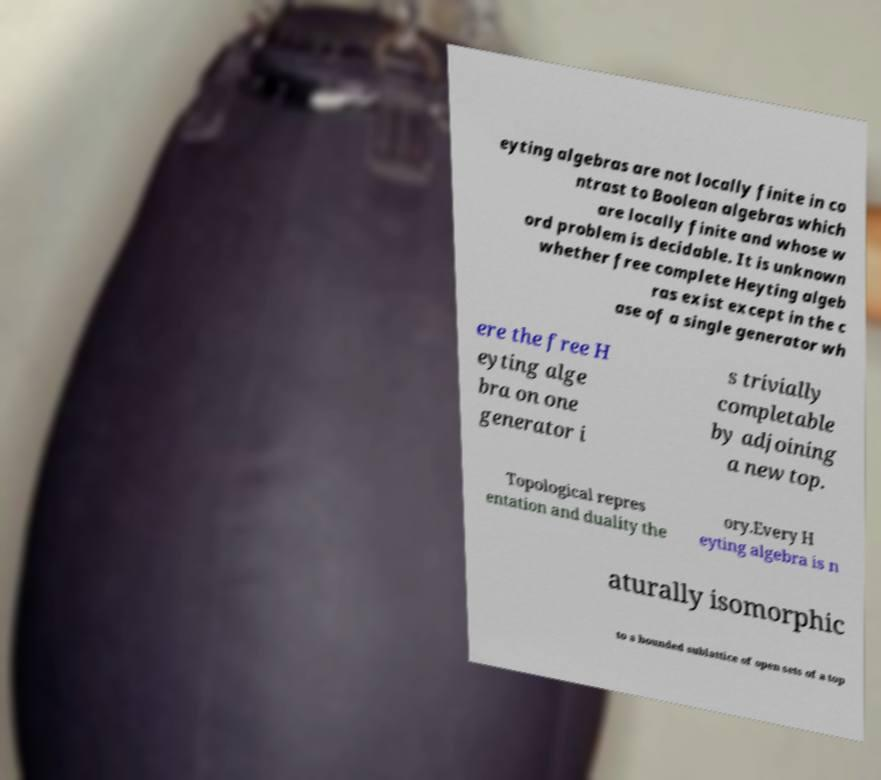Can you accurately transcribe the text from the provided image for me? eyting algebras are not locally finite in co ntrast to Boolean algebras which are locally finite and whose w ord problem is decidable. It is unknown whether free complete Heyting algeb ras exist except in the c ase of a single generator wh ere the free H eyting alge bra on one generator i s trivially completable by adjoining a new top. Topological repres entation and duality the ory.Every H eyting algebra is n aturally isomorphic to a bounded sublattice of open sets of a top 